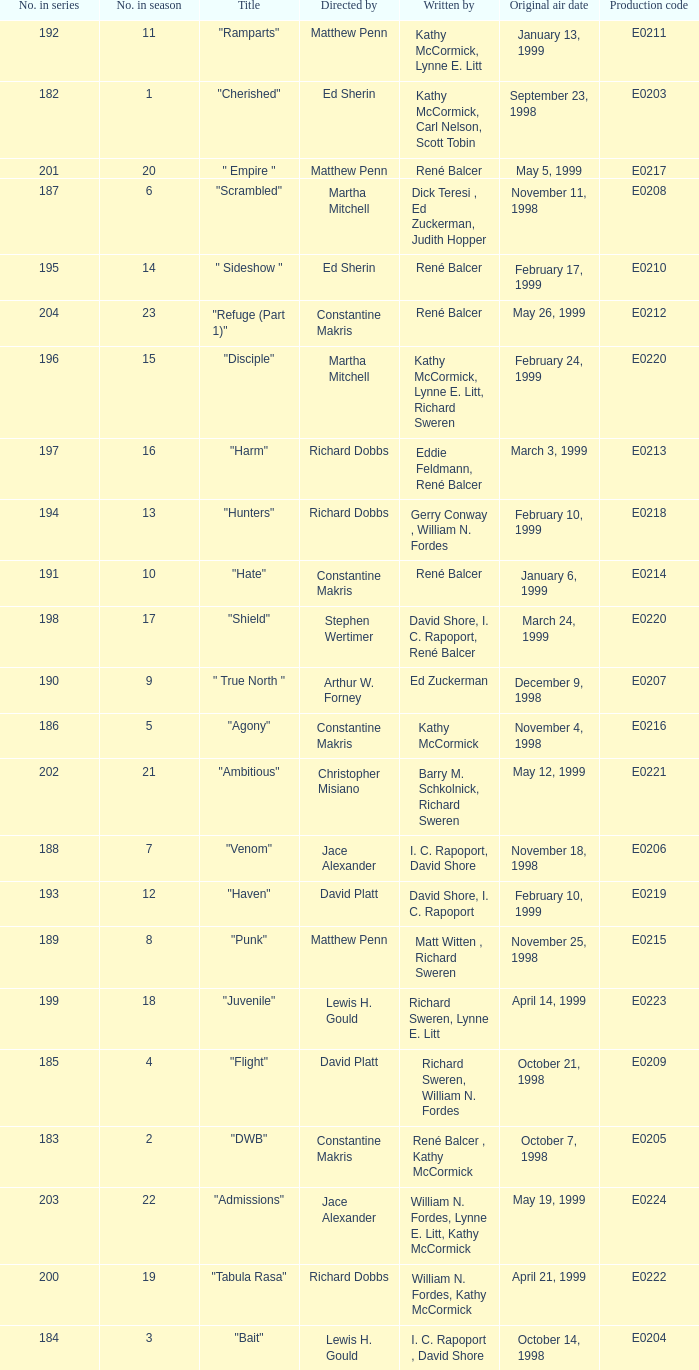What is the title of the episode with the original air date October 21, 1998? "Flight". 